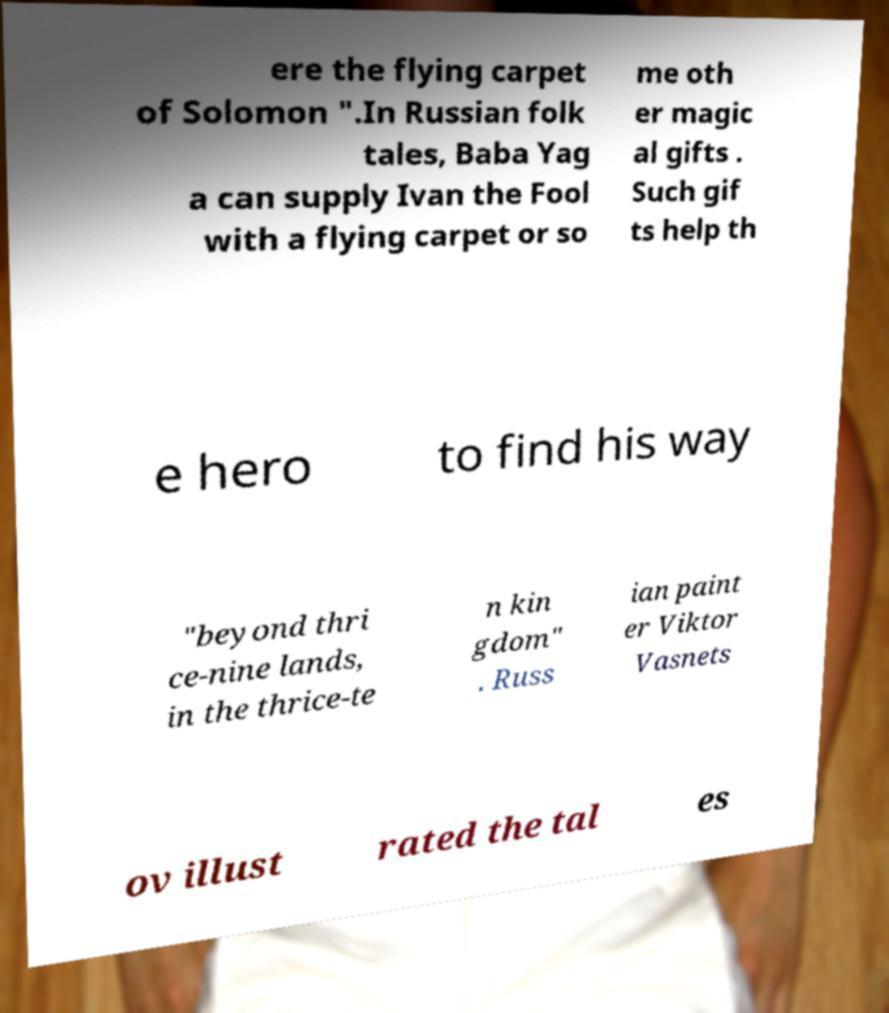Please identify and transcribe the text found in this image. ere the flying carpet of Solomon ".In Russian folk tales, Baba Yag a can supply Ivan the Fool with a flying carpet or so me oth er magic al gifts . Such gif ts help th e hero to find his way "beyond thri ce-nine lands, in the thrice-te n kin gdom" . Russ ian paint er Viktor Vasnets ov illust rated the tal es 